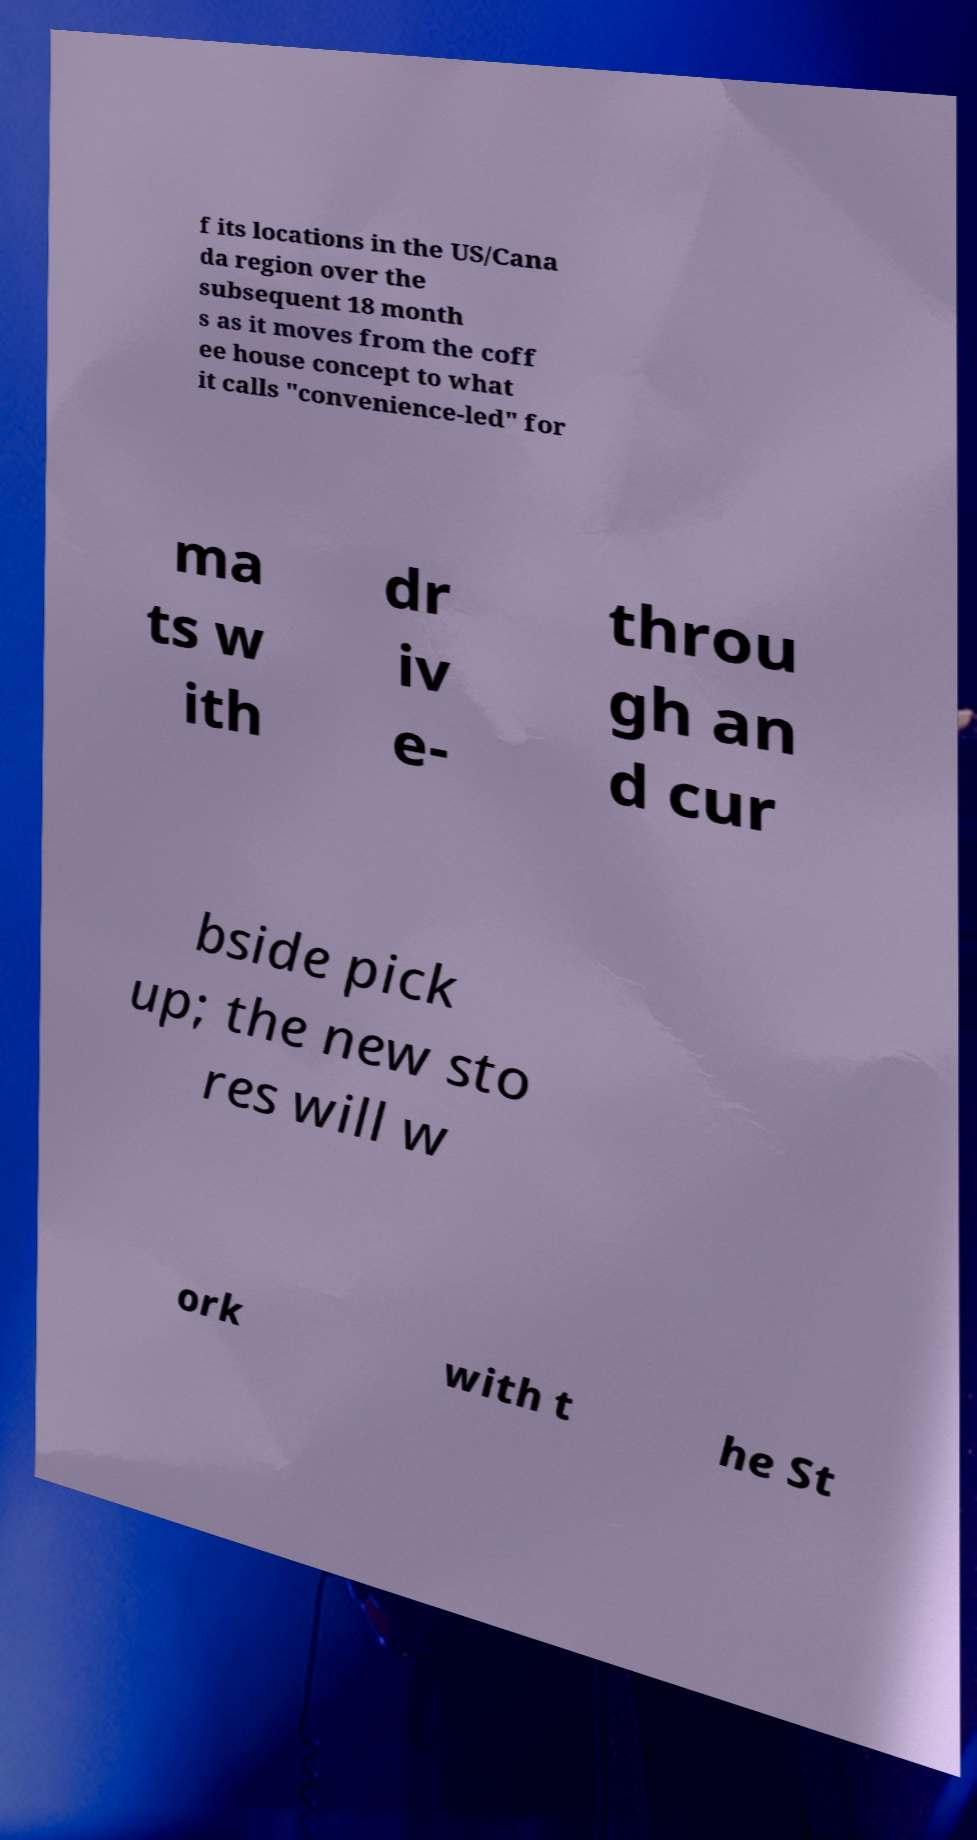What messages or text are displayed in this image? I need them in a readable, typed format. f its locations in the US/Cana da region over the subsequent 18 month s as it moves from the coff ee house concept to what it calls "convenience-led" for ma ts w ith dr iv e- throu gh an d cur bside pick up; the new sto res will w ork with t he St 